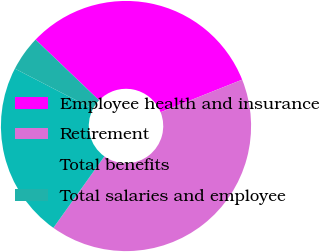Convert chart. <chart><loc_0><loc_0><loc_500><loc_500><pie_chart><fcel>Employee health and insurance<fcel>Retirement<fcel>Total benefits<fcel>Total salaries and employee<nl><fcel>31.82%<fcel>40.91%<fcel>22.73%<fcel>4.55%<nl></chart> 